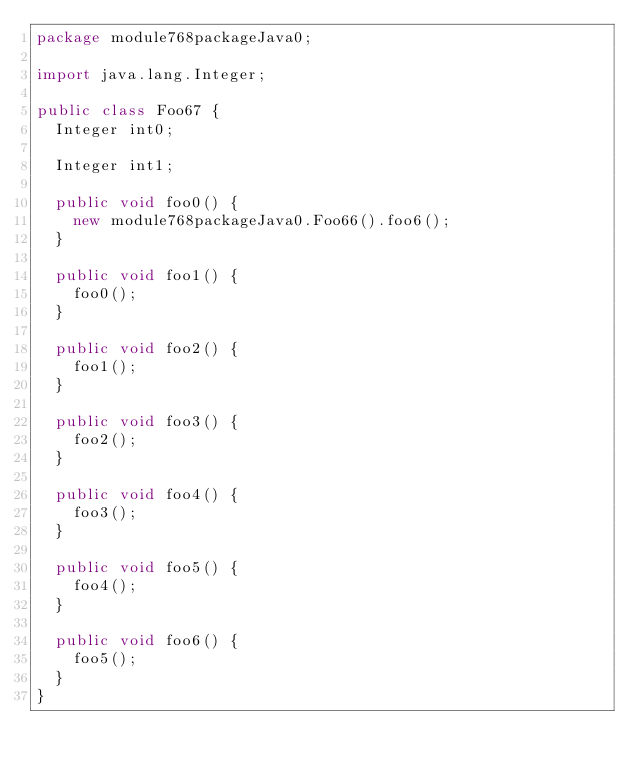<code> <loc_0><loc_0><loc_500><loc_500><_Java_>package module768packageJava0;

import java.lang.Integer;

public class Foo67 {
  Integer int0;

  Integer int1;

  public void foo0() {
    new module768packageJava0.Foo66().foo6();
  }

  public void foo1() {
    foo0();
  }

  public void foo2() {
    foo1();
  }

  public void foo3() {
    foo2();
  }

  public void foo4() {
    foo3();
  }

  public void foo5() {
    foo4();
  }

  public void foo6() {
    foo5();
  }
}
</code> 